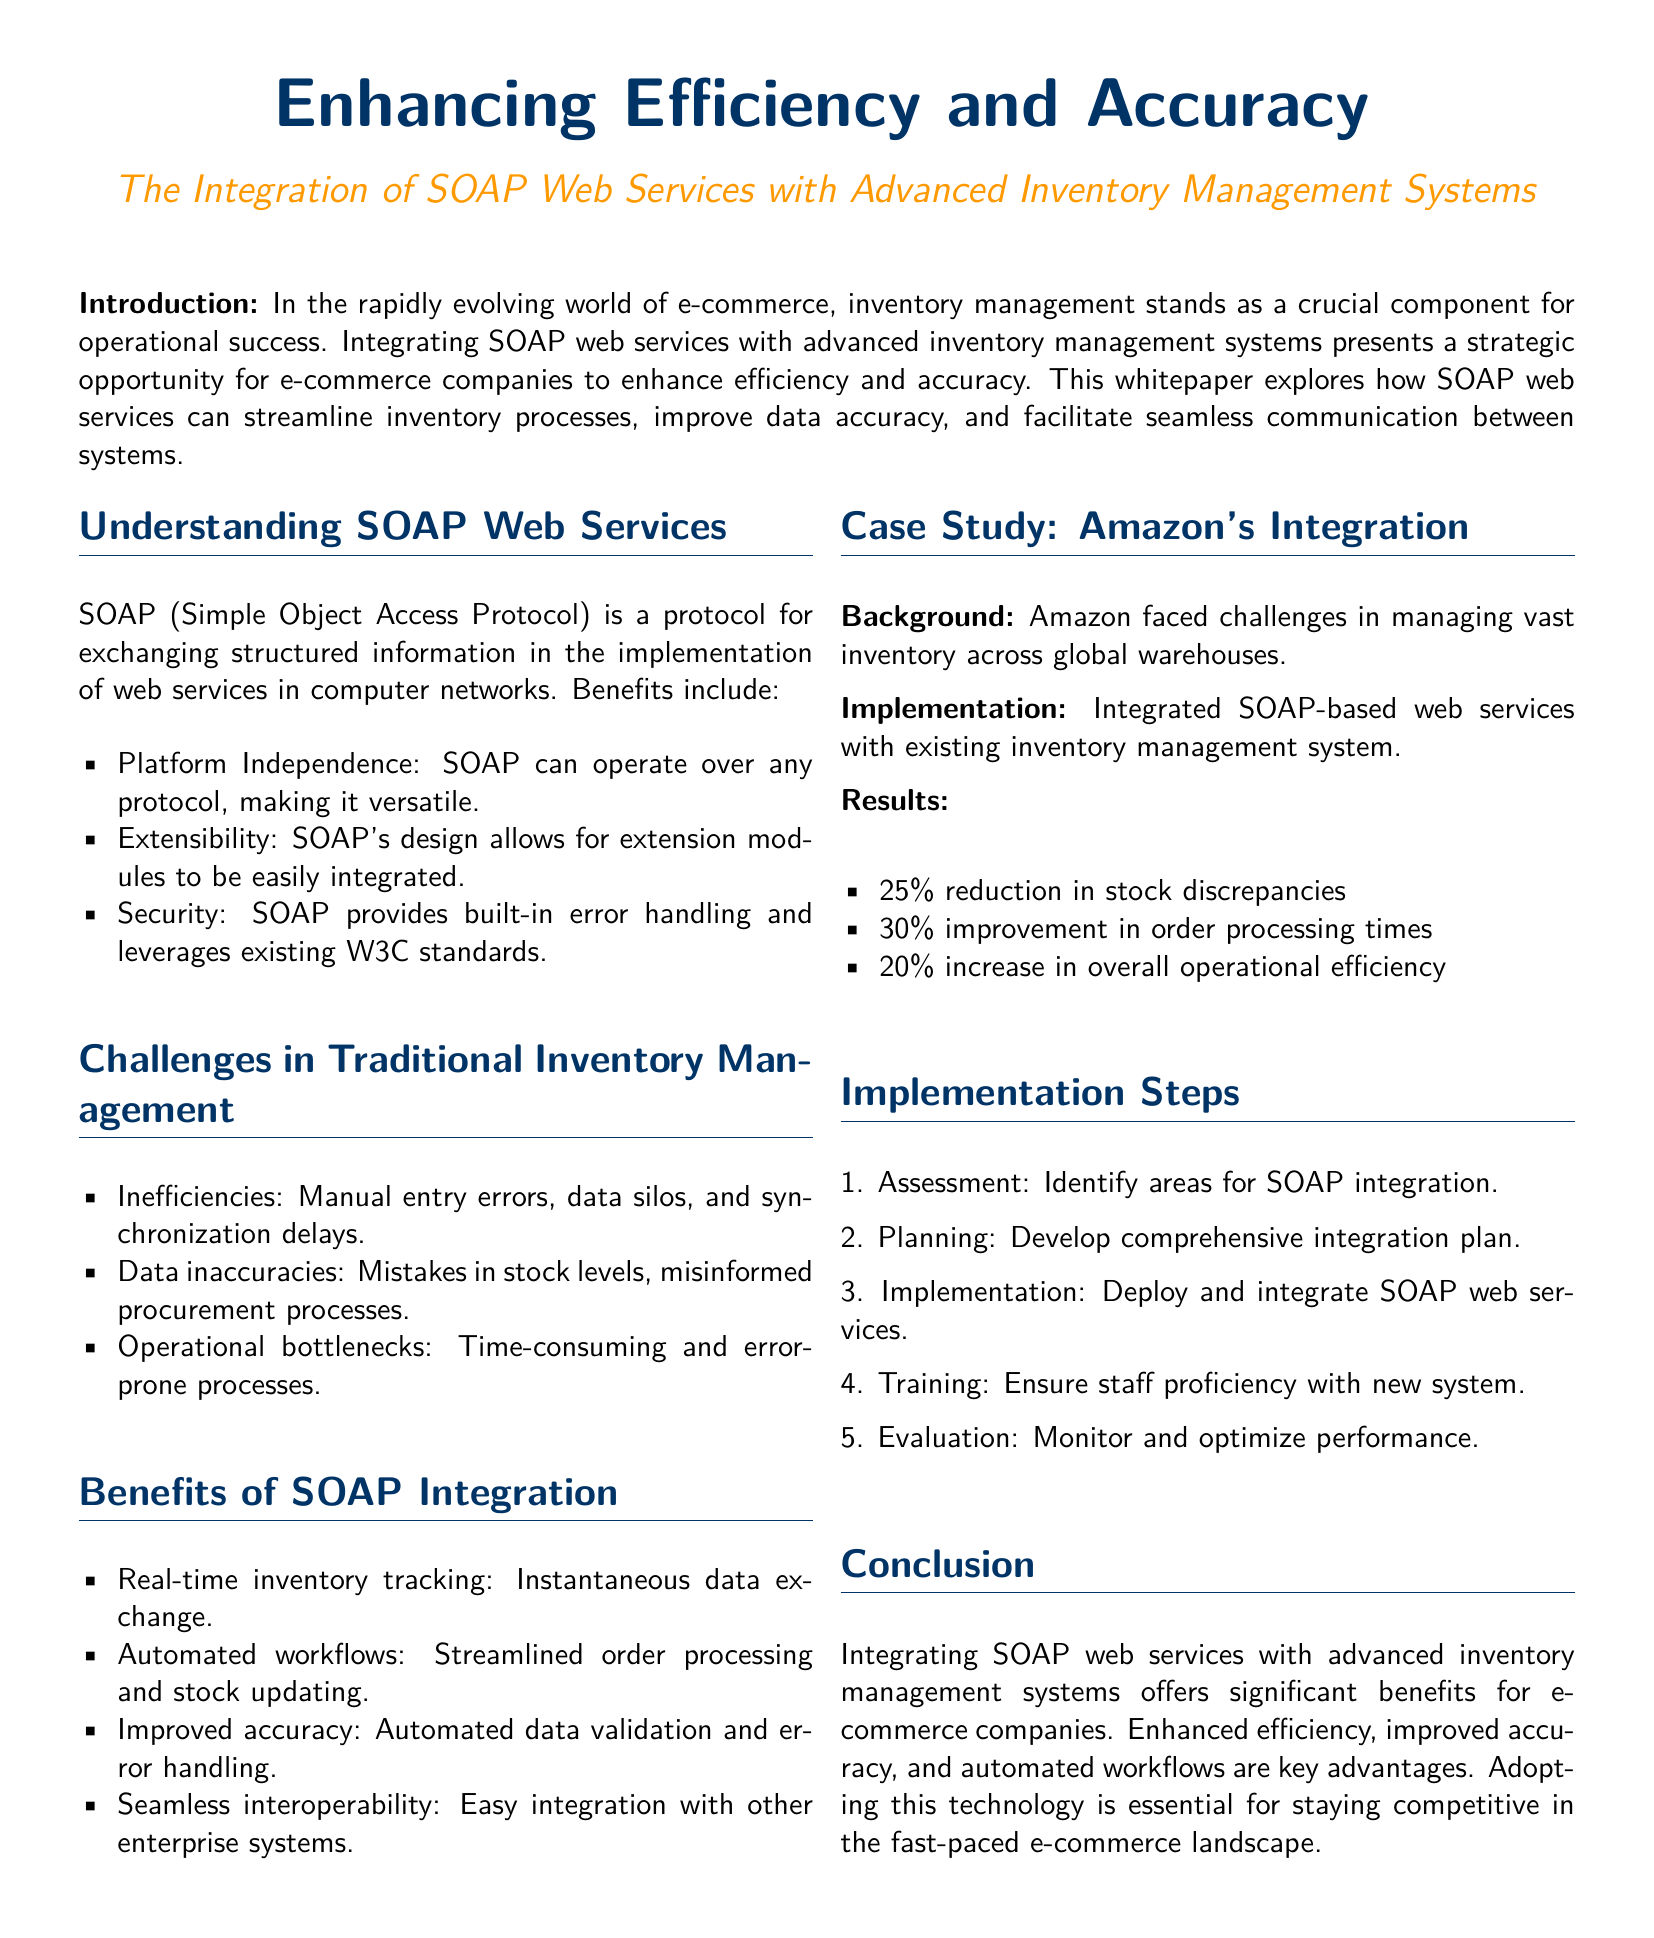What is the title of the whitepaper? The title is clearly stated at the beginning of the document, emphasizing the focus on SOAP web services and inventory management systems.
Answer: Enhancing Efficiency and Accuracy: The Integration of SOAP Web Services with Advanced Inventory Management Systems What protocol is discussed in the document? The document specifically mentions the protocol for exchanging structured information in web services as SOAP.
Answer: SOAP What percentage reduction in stock discrepancies did Amazon achieve? The case study details specific improvements Amazon experienced, including the percentage reduction in stock discrepancies.
Answer: 25% What is one key benefit of SOAP integration mentioned? The document lists several benefits, focusing on features that enhance inventory management processes.
Answer: Real-time inventory tracking What is the first step in the implementation process? The implementation steps are outlined in a numerical format, starting with the initial assessment task.
Answer: Assessment What problem in traditional inventory management is highlighted? The document enumerates challenges in traditional inventory systems, particularly emphasizing on certain common issues.
Answer: Inefficiencies How much did order processing times improve by after integration? The case study provides quantitative results reflecting improvements to order processing times as a result of implementing SOAP web services.
Answer: 30% What percent increase in operational efficiency did Amazon see? The case study concludes with specific performance improvements quantifying the operational outcomes for Amazon.
Answer: 20% 